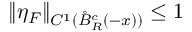Convert formula to latex. <formula><loc_0><loc_0><loc_500><loc_500>\| \eta _ { F } \| _ { C ^ { 1 } ( \mathring { B } _ { R } ^ { c } ( - x ) ) } \leq 1</formula> 